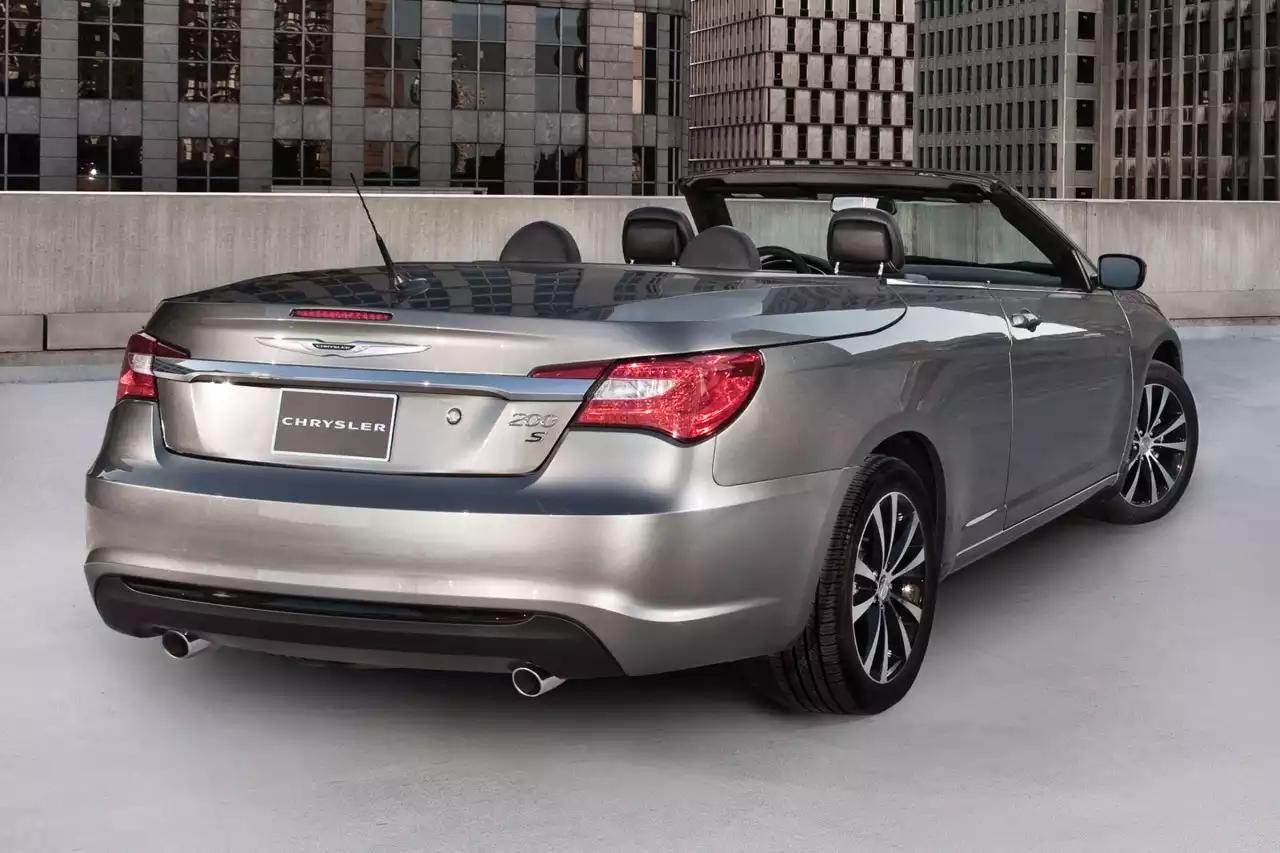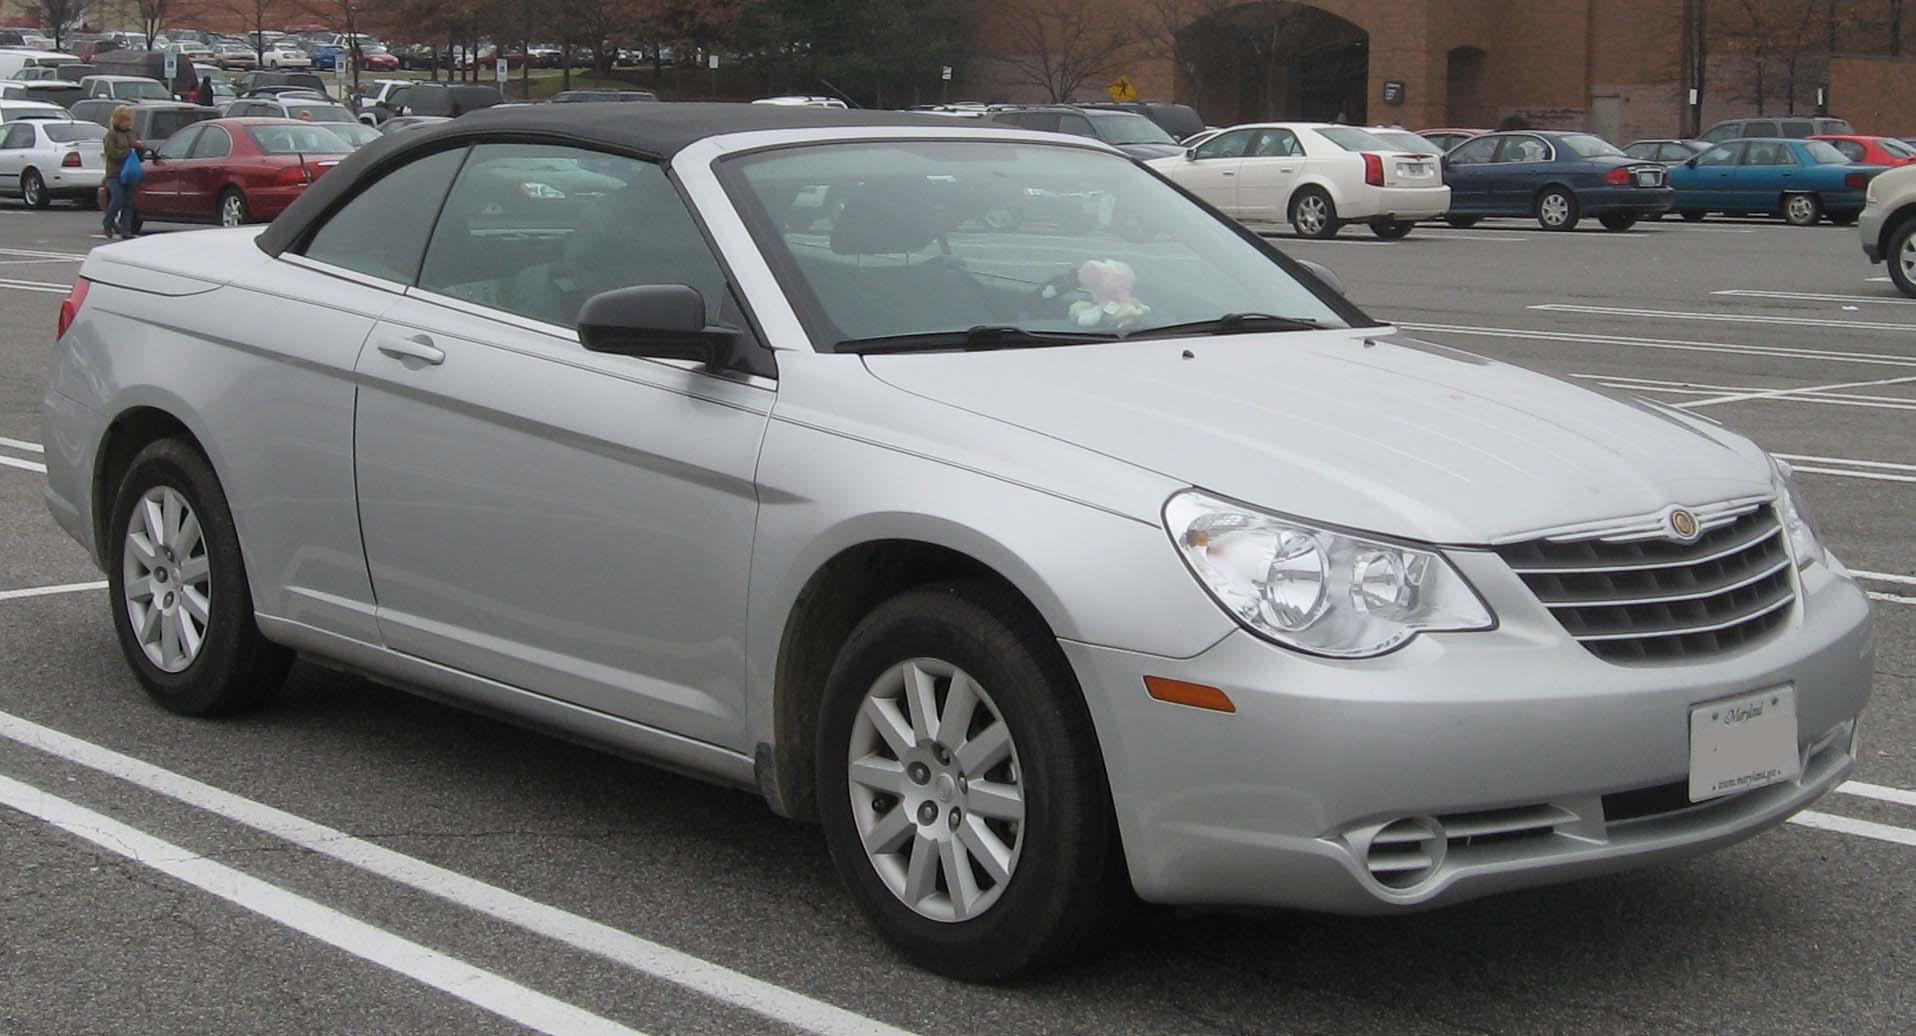The first image is the image on the left, the second image is the image on the right. For the images displayed, is the sentence "The car in the image on the right has a top." factually correct? Answer yes or no. Yes. The first image is the image on the left, the second image is the image on the right. For the images shown, is this caption "One parked car has it's top fully open, and the other parked car has it's hood fully closed." true? Answer yes or no. Yes. 